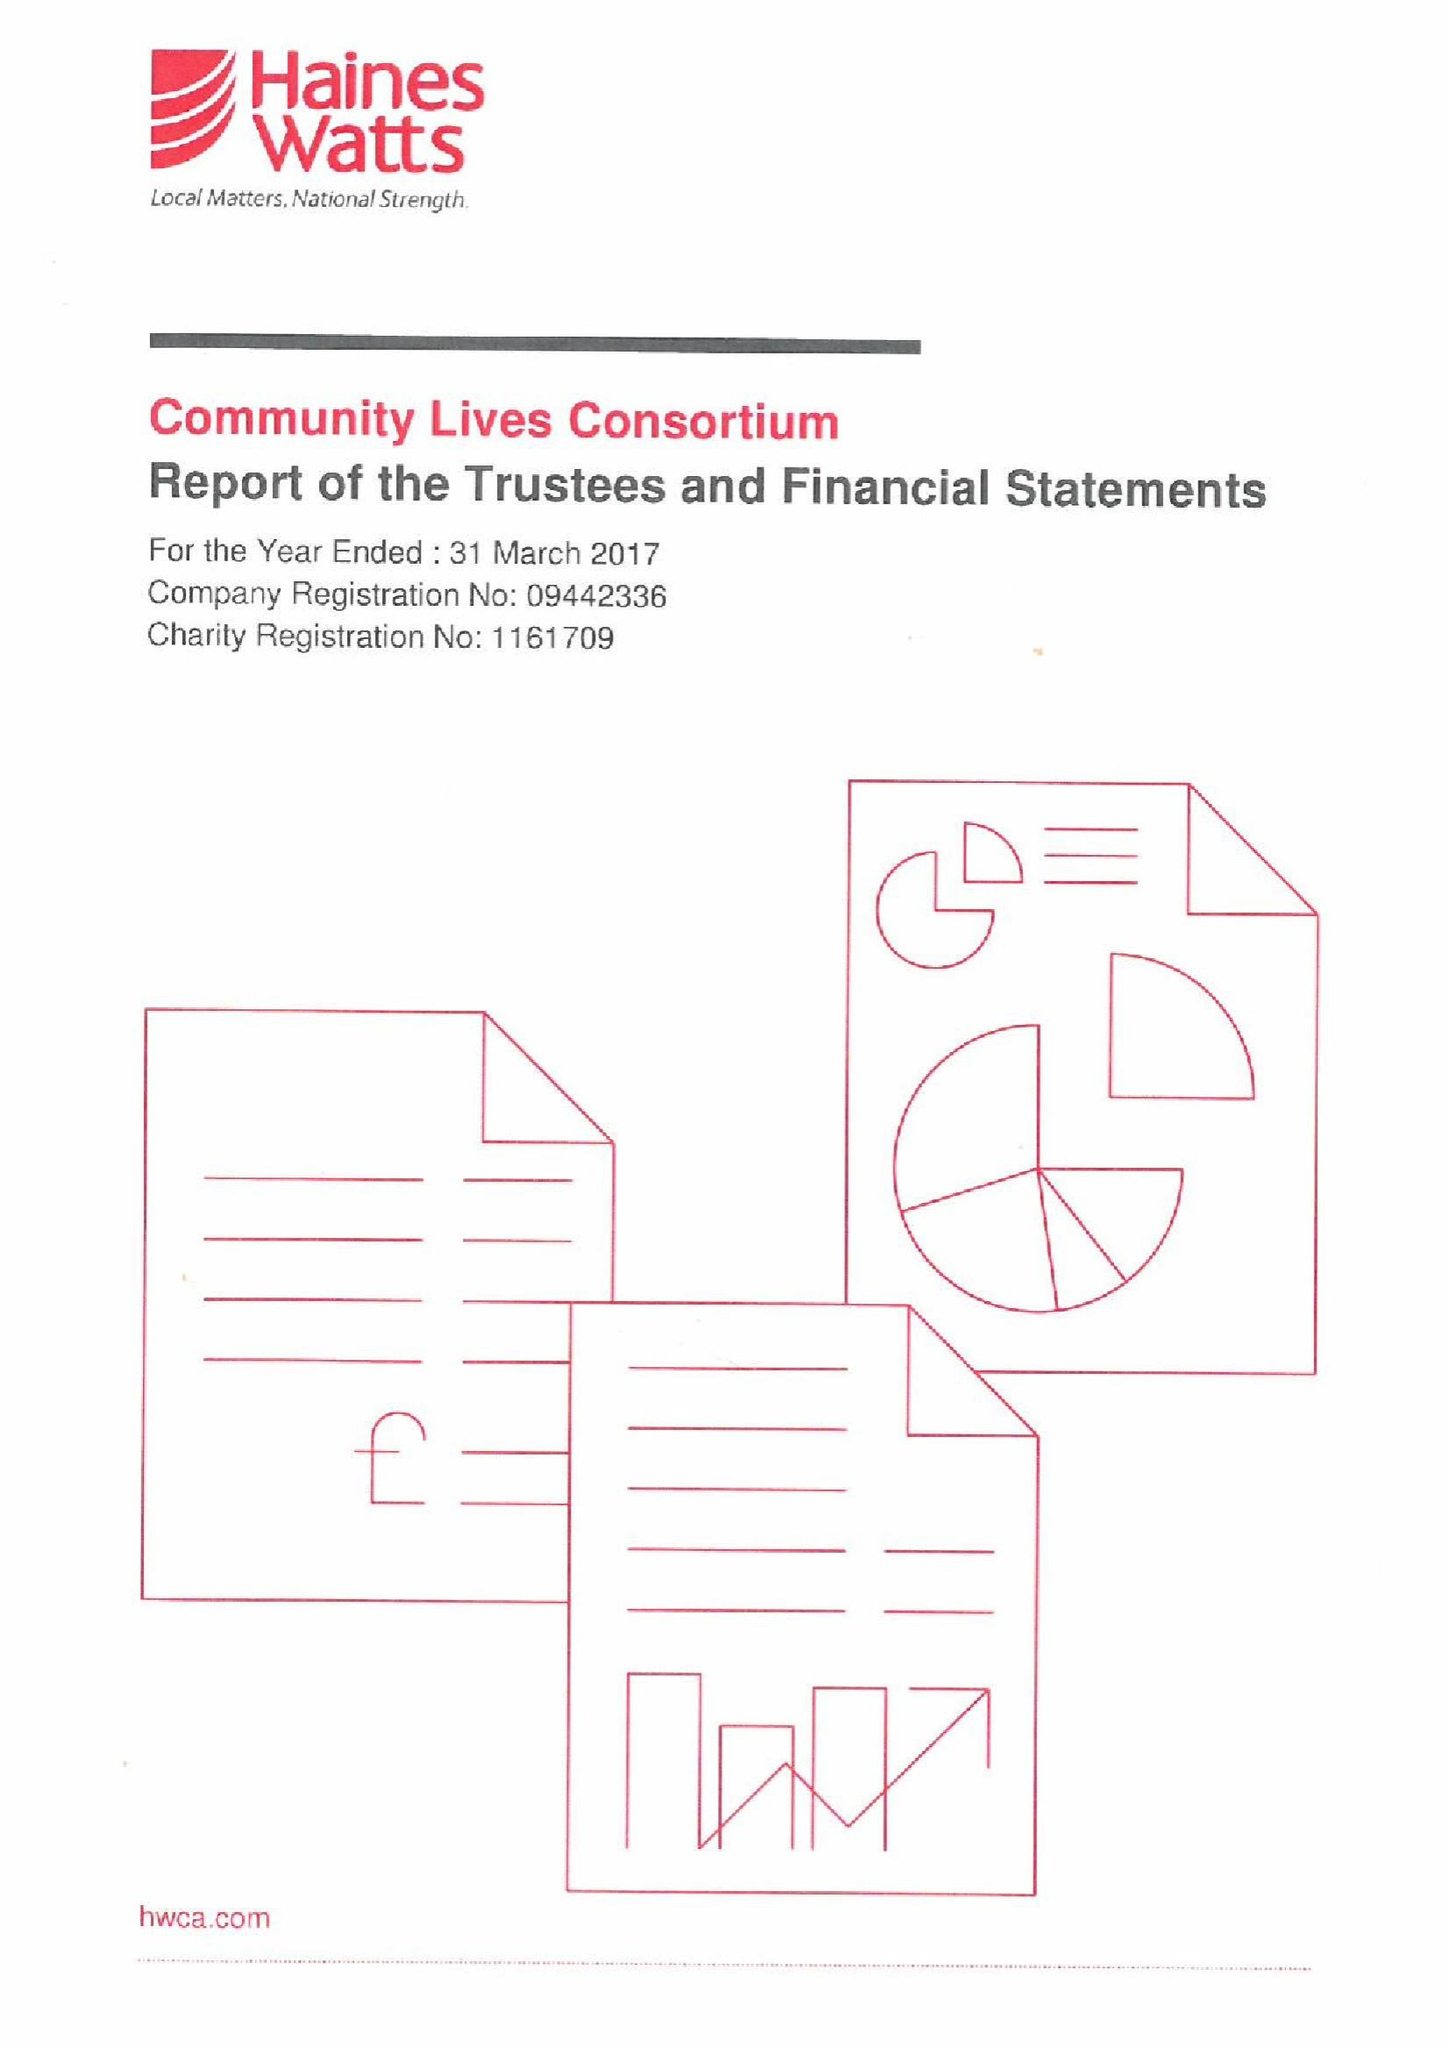What is the value for the address__post_town?
Answer the question using a single word or phrase. SWANSEA 